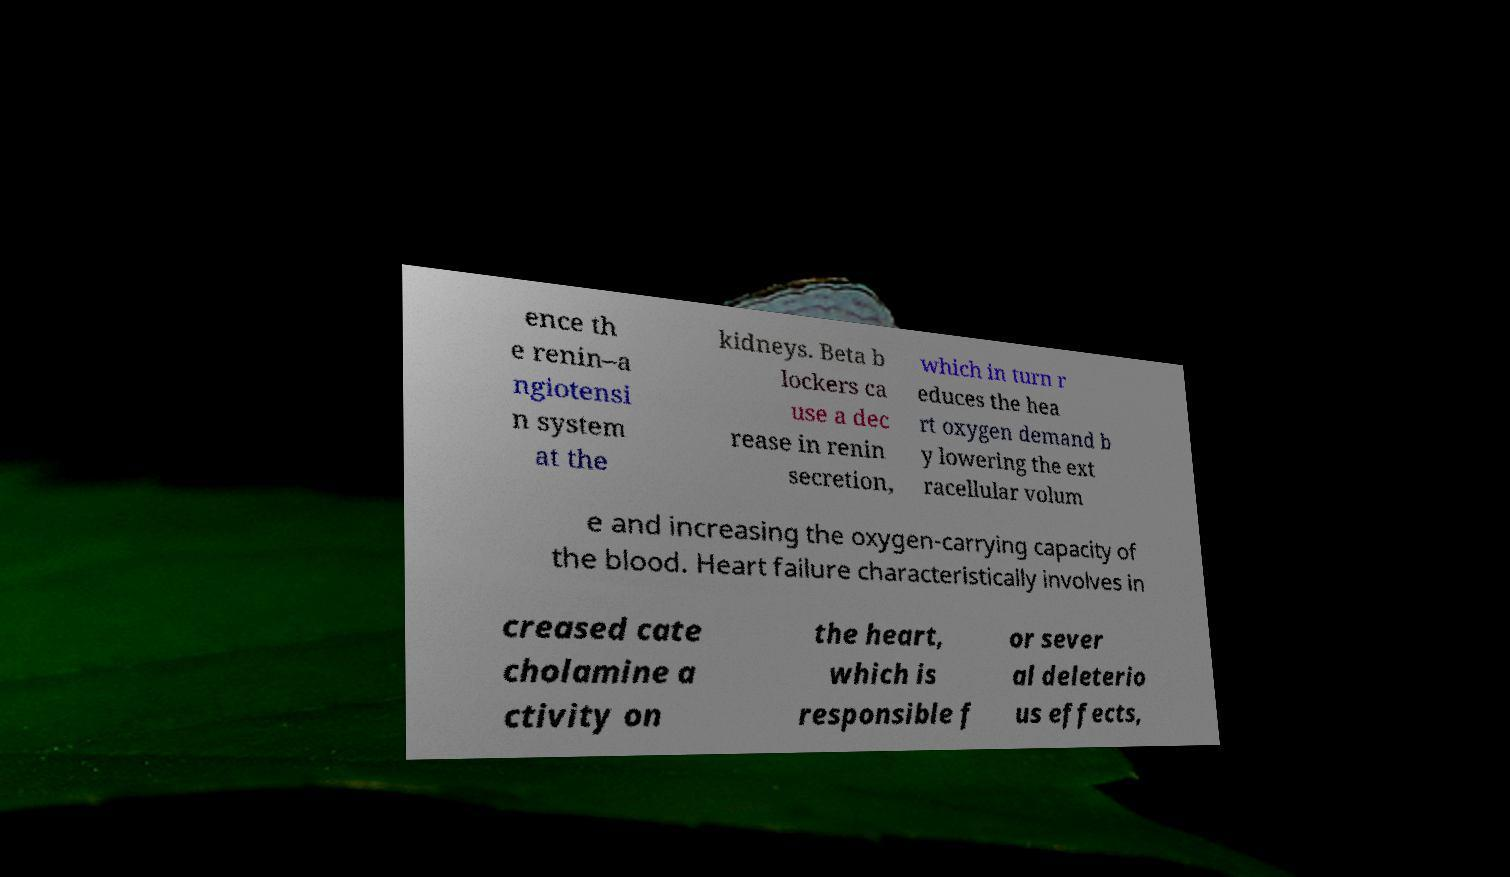I need the written content from this picture converted into text. Can you do that? ence th e renin–a ngiotensi n system at the kidneys. Beta b lockers ca use a dec rease in renin secretion, which in turn r educes the hea rt oxygen demand b y lowering the ext racellular volum e and increasing the oxygen-carrying capacity of the blood. Heart failure characteristically involves in creased cate cholamine a ctivity on the heart, which is responsible f or sever al deleterio us effects, 